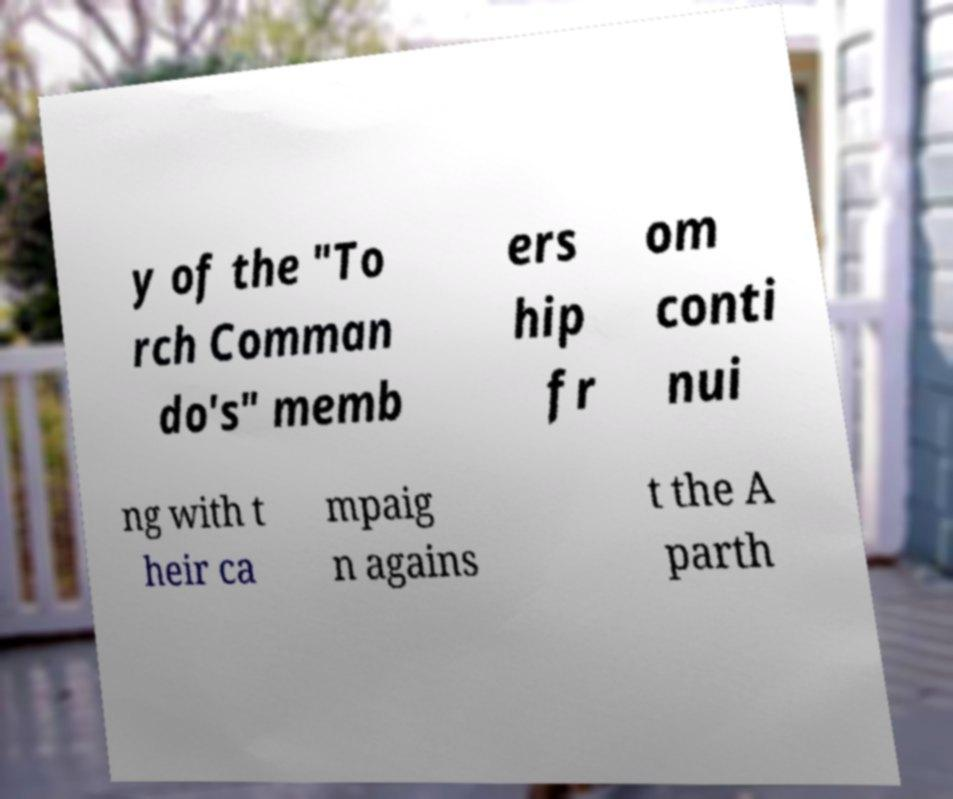I need the written content from this picture converted into text. Can you do that? y of the "To rch Comman do's" memb ers hip fr om conti nui ng with t heir ca mpaig n agains t the A parth 